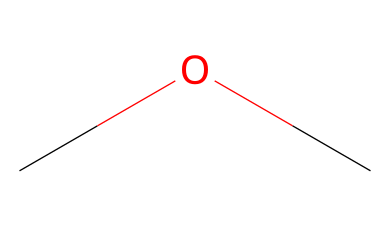What is the name of this chemical? The SMILES representation "COC" corresponds to the chemical name 'dimethyl ether,' which indicates it contains two methyl groups bonded through an ether linkage.
Answer: dimethyl ether How many carbon atoms are in this molecule? By examining the SMILES string "COC," we can see there are two 'C' characters representing two carbon atoms in the molecular structure.
Answer: 2 What type of functional group does this compound contain? The presence of the ether bond depicted by the 'C-O-C' structure indicates the compound contains an ether functional group.
Answer: ether What is the total number of hydrogen atoms in dimethyl ether? Each carbon in dimethyl ether (C) has three hydrogen atoms in total, minus one for the connection to the oxygen, resulting in (2x3) - 1 = 5 hydrogen atoms overall.
Answer: 6 Is dimethyl ether polar or nonpolar? The arrangement of the atoms and the presence of the oxygen atom suggest that dimethyl ether has polar characteristics due to the electronegativity difference between carbon and oxygen.
Answer: polar Can this chemical be used as a propellant in aerosol products? Yes, dimethyl ether is often used as a propellant due to its ability to vaporize easily and disperse fragrance, making it suitable for aerosol applications.
Answer: yes What is a primary use of dimethyl ether in household products? Dimethyl ether is commonly used in aerosol air fresheners as it effectively carries fragrances and disperses them in the air.
Answer: air fresheners 